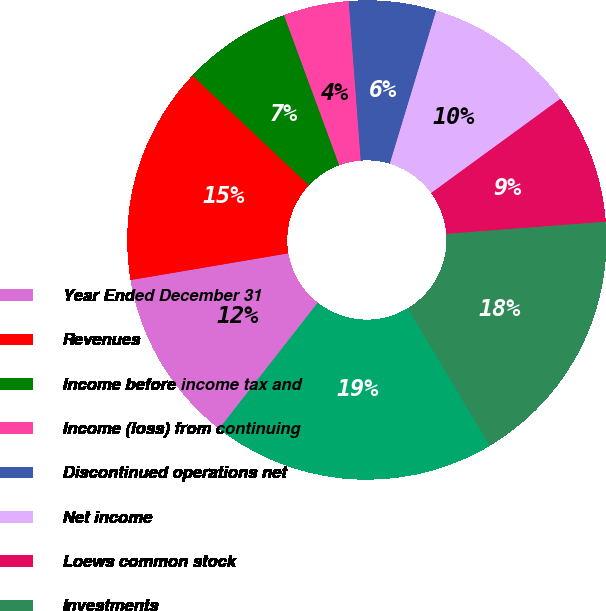<chart> <loc_0><loc_0><loc_500><loc_500><pie_chart><fcel>Year Ended December 31<fcel>Revenues<fcel>Income before income tax and<fcel>Income (loss) from continuing<fcel>Discontinued operations net<fcel>Net income<fcel>Loews common stock<fcel>Investments<fcel>Total assets<nl><fcel>11.76%<fcel>14.71%<fcel>7.35%<fcel>4.41%<fcel>5.88%<fcel>10.29%<fcel>8.82%<fcel>17.65%<fcel>19.12%<nl></chart> 